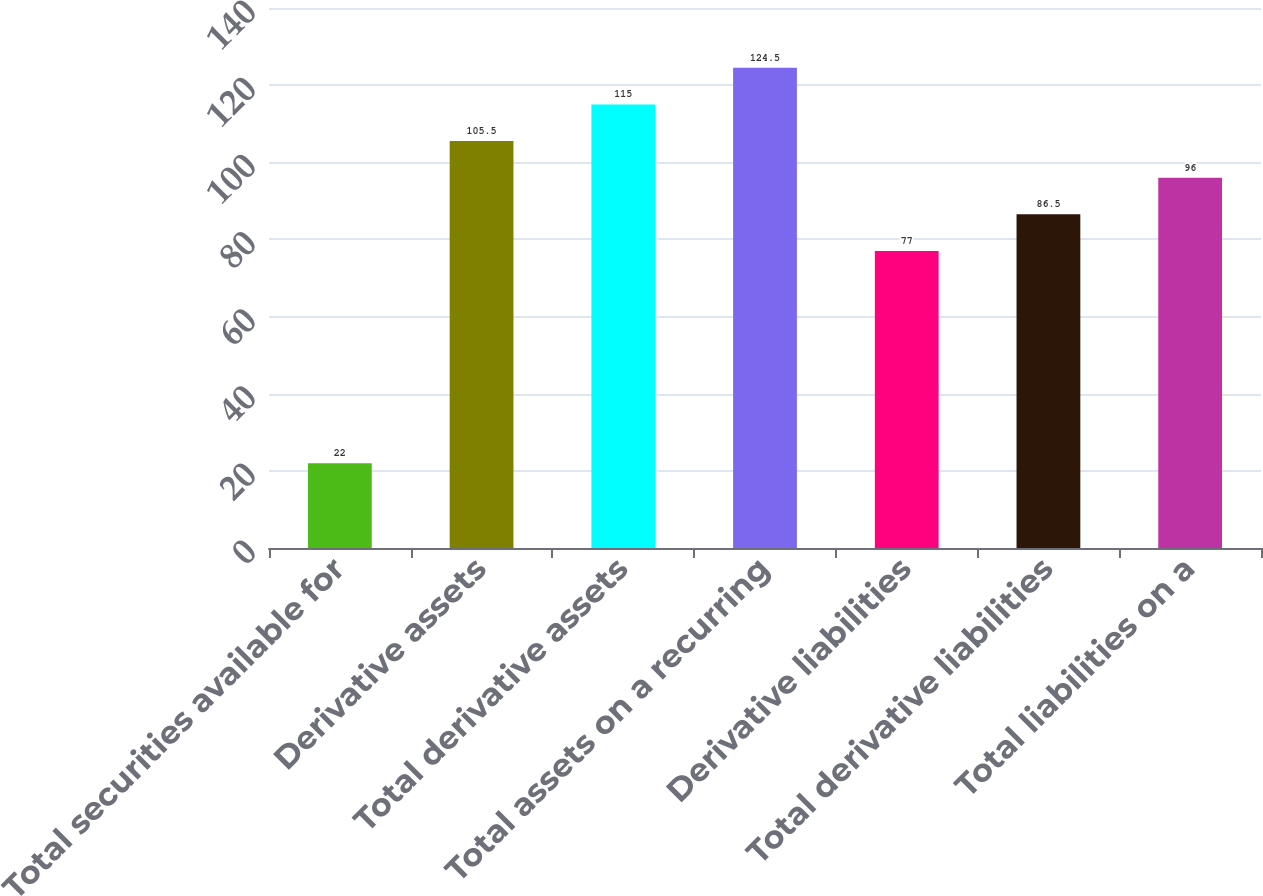<chart> <loc_0><loc_0><loc_500><loc_500><bar_chart><fcel>Total securities available for<fcel>Derivative assets<fcel>Total derivative assets<fcel>Total assets on a recurring<fcel>Derivative liabilities<fcel>Total derivative liabilities<fcel>Total liabilities on a<nl><fcel>22<fcel>105.5<fcel>115<fcel>124.5<fcel>77<fcel>86.5<fcel>96<nl></chart> 